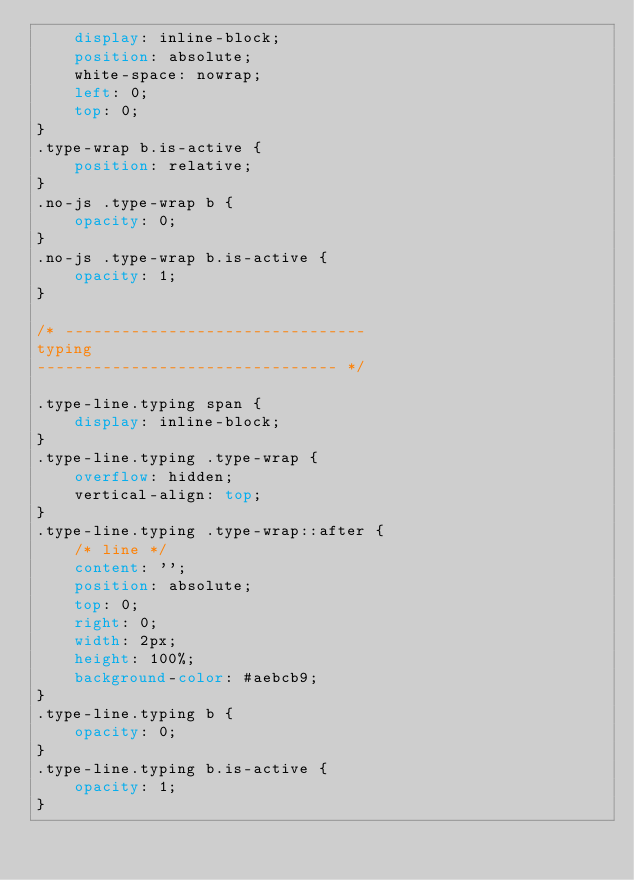Convert code to text. <code><loc_0><loc_0><loc_500><loc_500><_CSS_>    display: inline-block;
    position: absolute;
    white-space: nowrap;
    left: 0;
    top: 0;
}
.type-wrap b.is-active {
    position: relative;
}
.no-js .type-wrap b {
    opacity: 0;
}
.no-js .type-wrap b.is-active {
    opacity: 1;
}

/* -------------------------------- 
typing 
-------------------------------- */

.type-line.typing span {
    display: inline-block;
}
.type-line.typing .type-wrap {
    overflow: hidden;
    vertical-align: top;
}
.type-line.typing .type-wrap::after {
    /* line */
    content: '';
    position: absolute;
    top: 0;
    right: 0;
    width: 2px;
    height: 100%;
    background-color: #aebcb9;
}
.type-line.typing b {
    opacity: 0;
}
.type-line.typing b.is-active {
    opacity: 1;
}</code> 